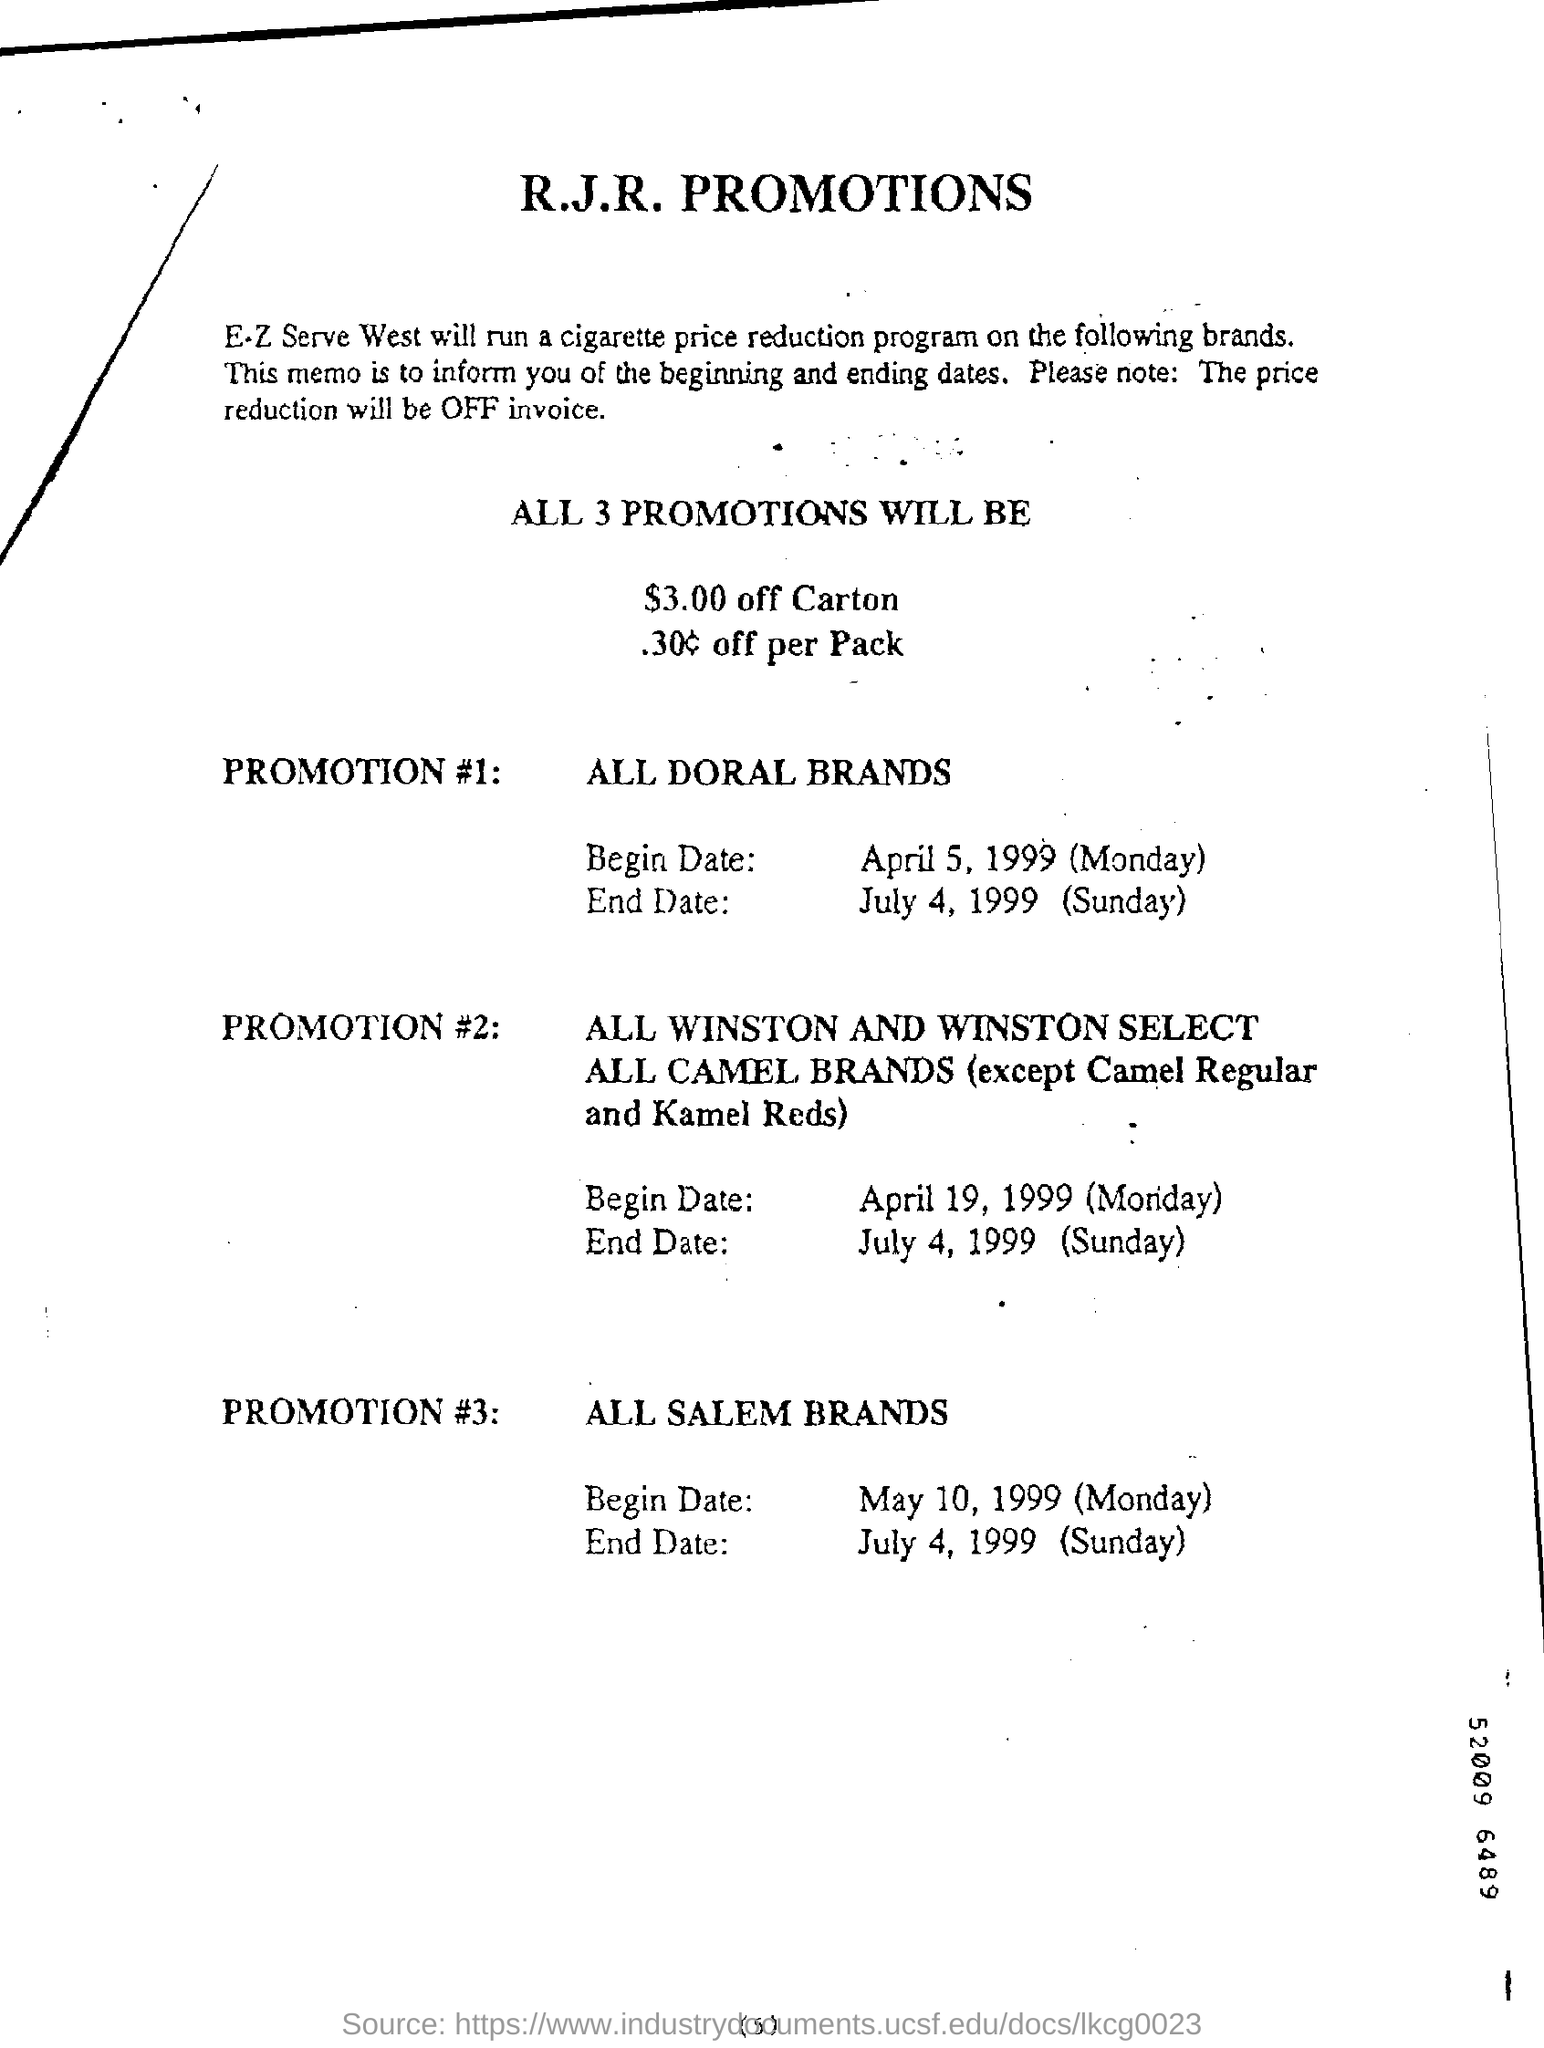Draw attention to some important aspects in this diagram. All Doral brands are eligible for Promotion #1. All Salem brands are eligible for Promotion #3. 